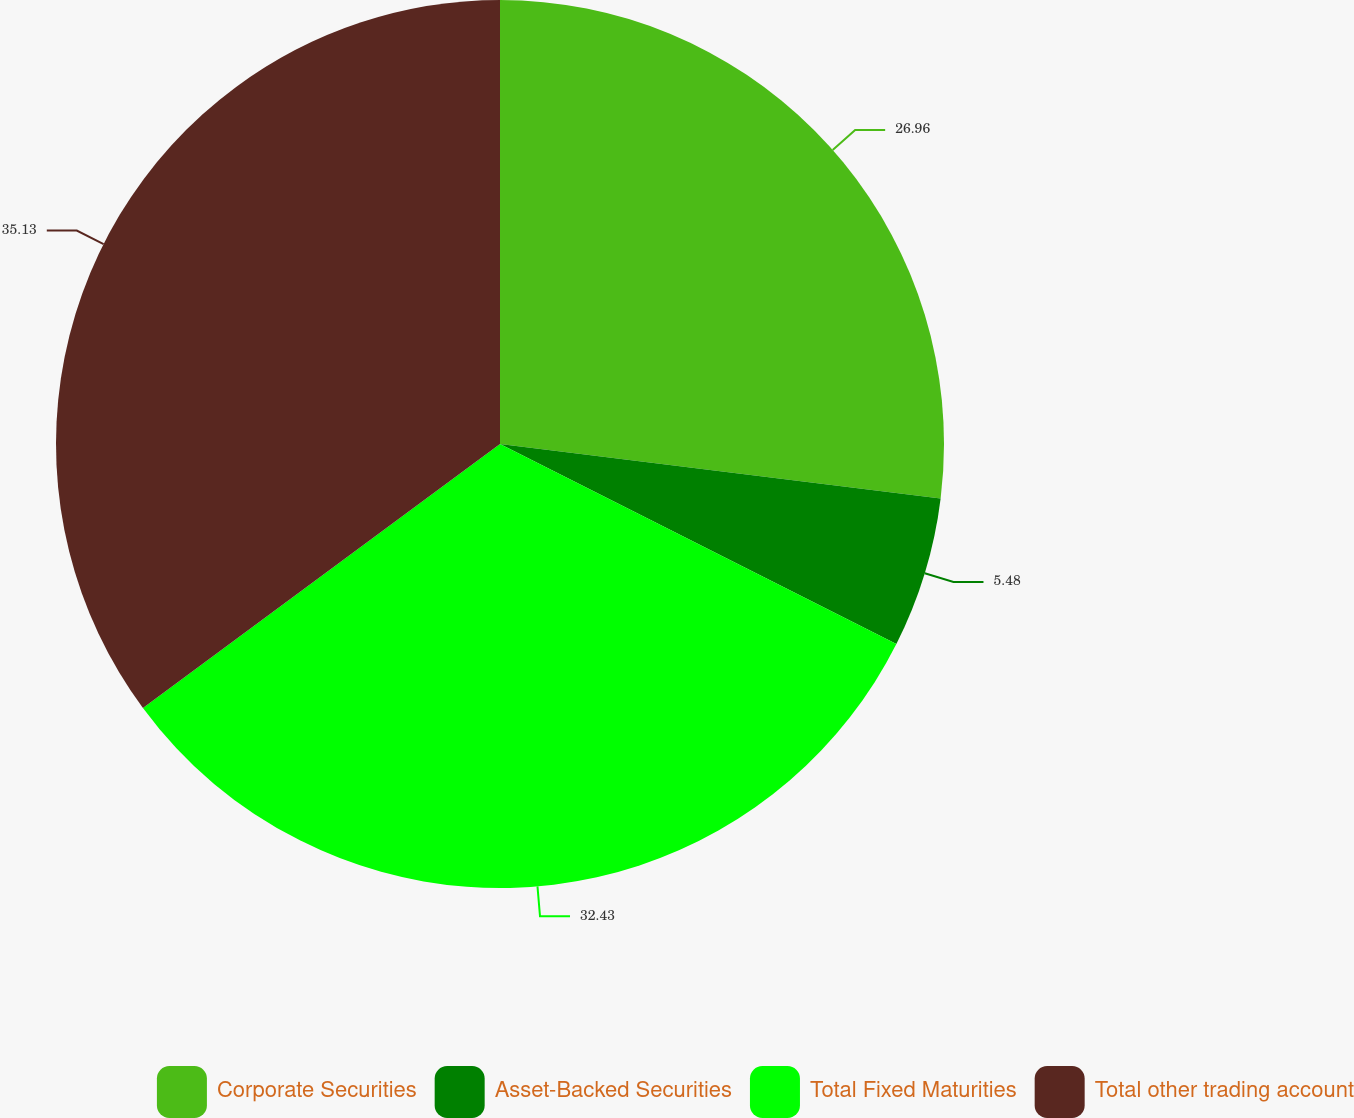<chart> <loc_0><loc_0><loc_500><loc_500><pie_chart><fcel>Corporate Securities<fcel>Asset-Backed Securities<fcel>Total Fixed Maturities<fcel>Total other trading account<nl><fcel>26.96%<fcel>5.48%<fcel>32.43%<fcel>35.13%<nl></chart> 